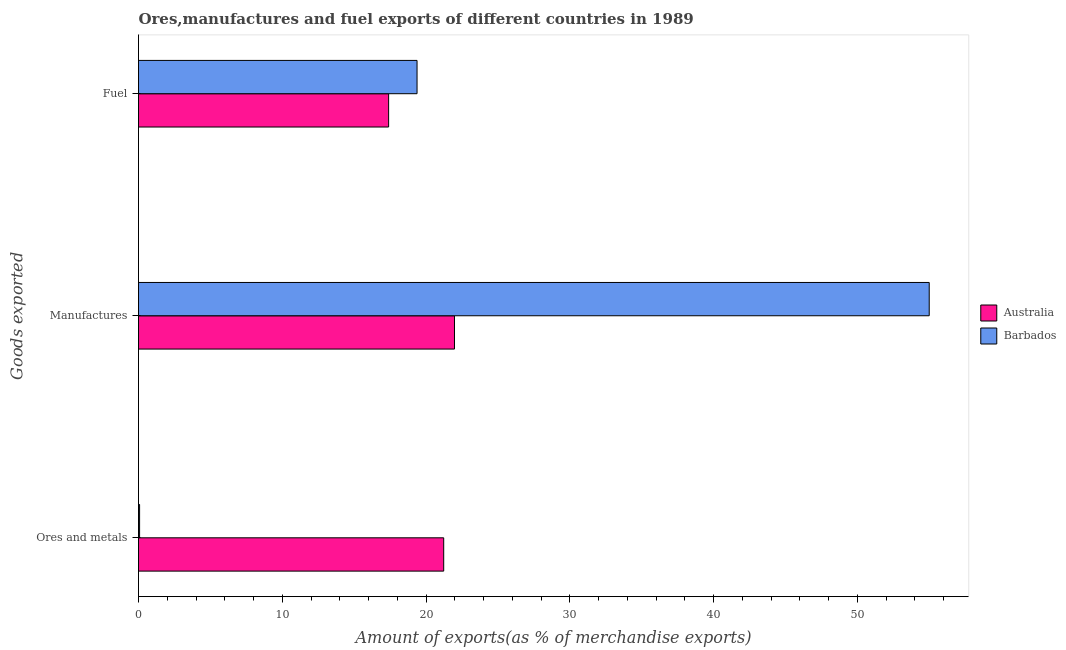Are the number of bars per tick equal to the number of legend labels?
Give a very brief answer. Yes. What is the label of the 1st group of bars from the top?
Your response must be concise. Fuel. What is the percentage of ores and metals exports in Australia?
Offer a terse response. 21.23. Across all countries, what is the maximum percentage of fuel exports?
Your response must be concise. 19.37. Across all countries, what is the minimum percentage of manufactures exports?
Your response must be concise. 21.98. In which country was the percentage of ores and metals exports maximum?
Keep it short and to the point. Australia. What is the total percentage of manufactures exports in the graph?
Your answer should be compact. 76.97. What is the difference between the percentage of fuel exports in Australia and that in Barbados?
Offer a terse response. -1.98. What is the difference between the percentage of manufactures exports in Australia and the percentage of fuel exports in Barbados?
Offer a very short reply. 2.6. What is the average percentage of fuel exports per country?
Ensure brevity in your answer.  18.38. What is the difference between the percentage of fuel exports and percentage of manufactures exports in Barbados?
Your response must be concise. -35.62. In how many countries, is the percentage of ores and metals exports greater than 50 %?
Ensure brevity in your answer.  0. What is the ratio of the percentage of manufactures exports in Barbados to that in Australia?
Offer a very short reply. 2.5. What is the difference between the highest and the second highest percentage of ores and metals exports?
Provide a succinct answer. 21.15. What is the difference between the highest and the lowest percentage of manufactures exports?
Your answer should be compact. 33.02. In how many countries, is the percentage of fuel exports greater than the average percentage of fuel exports taken over all countries?
Ensure brevity in your answer.  1. What does the 2nd bar from the top in Manufactures represents?
Offer a terse response. Australia. Are all the bars in the graph horizontal?
Your answer should be compact. Yes. How many countries are there in the graph?
Keep it short and to the point. 2. What is the difference between two consecutive major ticks on the X-axis?
Keep it short and to the point. 10. Are the values on the major ticks of X-axis written in scientific E-notation?
Your answer should be very brief. No. Where does the legend appear in the graph?
Keep it short and to the point. Center right. What is the title of the graph?
Ensure brevity in your answer.  Ores,manufactures and fuel exports of different countries in 1989. Does "Swaziland" appear as one of the legend labels in the graph?
Make the answer very short. No. What is the label or title of the X-axis?
Give a very brief answer. Amount of exports(as % of merchandise exports). What is the label or title of the Y-axis?
Your answer should be compact. Goods exported. What is the Amount of exports(as % of merchandise exports) in Australia in Ores and metals?
Offer a terse response. 21.23. What is the Amount of exports(as % of merchandise exports) of Barbados in Ores and metals?
Your answer should be very brief. 0.08. What is the Amount of exports(as % of merchandise exports) in Australia in Manufactures?
Offer a terse response. 21.98. What is the Amount of exports(as % of merchandise exports) in Barbados in Manufactures?
Offer a terse response. 54.99. What is the Amount of exports(as % of merchandise exports) of Australia in Fuel?
Make the answer very short. 17.39. What is the Amount of exports(as % of merchandise exports) of Barbados in Fuel?
Offer a terse response. 19.37. Across all Goods exported, what is the maximum Amount of exports(as % of merchandise exports) of Australia?
Your answer should be compact. 21.98. Across all Goods exported, what is the maximum Amount of exports(as % of merchandise exports) in Barbados?
Keep it short and to the point. 54.99. Across all Goods exported, what is the minimum Amount of exports(as % of merchandise exports) in Australia?
Offer a very short reply. 17.39. Across all Goods exported, what is the minimum Amount of exports(as % of merchandise exports) of Barbados?
Provide a succinct answer. 0.08. What is the total Amount of exports(as % of merchandise exports) of Australia in the graph?
Your answer should be very brief. 60.6. What is the total Amount of exports(as % of merchandise exports) in Barbados in the graph?
Your answer should be compact. 74.44. What is the difference between the Amount of exports(as % of merchandise exports) of Australia in Ores and metals and that in Manufactures?
Make the answer very short. -0.75. What is the difference between the Amount of exports(as % of merchandise exports) in Barbados in Ores and metals and that in Manufactures?
Provide a short and direct response. -54.92. What is the difference between the Amount of exports(as % of merchandise exports) of Australia in Ores and metals and that in Fuel?
Keep it short and to the point. 3.83. What is the difference between the Amount of exports(as % of merchandise exports) of Barbados in Ores and metals and that in Fuel?
Offer a very short reply. -19.3. What is the difference between the Amount of exports(as % of merchandise exports) in Australia in Manufactures and that in Fuel?
Provide a succinct answer. 4.58. What is the difference between the Amount of exports(as % of merchandise exports) in Barbados in Manufactures and that in Fuel?
Your answer should be compact. 35.62. What is the difference between the Amount of exports(as % of merchandise exports) in Australia in Ores and metals and the Amount of exports(as % of merchandise exports) in Barbados in Manufactures?
Offer a very short reply. -33.77. What is the difference between the Amount of exports(as % of merchandise exports) of Australia in Ores and metals and the Amount of exports(as % of merchandise exports) of Barbados in Fuel?
Keep it short and to the point. 1.85. What is the difference between the Amount of exports(as % of merchandise exports) in Australia in Manufactures and the Amount of exports(as % of merchandise exports) in Barbados in Fuel?
Make the answer very short. 2.6. What is the average Amount of exports(as % of merchandise exports) of Australia per Goods exported?
Your answer should be compact. 20.2. What is the average Amount of exports(as % of merchandise exports) in Barbados per Goods exported?
Your response must be concise. 24.81. What is the difference between the Amount of exports(as % of merchandise exports) of Australia and Amount of exports(as % of merchandise exports) of Barbados in Ores and metals?
Give a very brief answer. 21.15. What is the difference between the Amount of exports(as % of merchandise exports) of Australia and Amount of exports(as % of merchandise exports) of Barbados in Manufactures?
Your response must be concise. -33.02. What is the difference between the Amount of exports(as % of merchandise exports) of Australia and Amount of exports(as % of merchandise exports) of Barbados in Fuel?
Keep it short and to the point. -1.98. What is the ratio of the Amount of exports(as % of merchandise exports) of Australia in Ores and metals to that in Manufactures?
Make the answer very short. 0.97. What is the ratio of the Amount of exports(as % of merchandise exports) of Barbados in Ores and metals to that in Manufactures?
Your response must be concise. 0. What is the ratio of the Amount of exports(as % of merchandise exports) of Australia in Ores and metals to that in Fuel?
Offer a terse response. 1.22. What is the ratio of the Amount of exports(as % of merchandise exports) of Barbados in Ores and metals to that in Fuel?
Your answer should be compact. 0. What is the ratio of the Amount of exports(as % of merchandise exports) in Australia in Manufactures to that in Fuel?
Your answer should be very brief. 1.26. What is the ratio of the Amount of exports(as % of merchandise exports) of Barbados in Manufactures to that in Fuel?
Keep it short and to the point. 2.84. What is the difference between the highest and the second highest Amount of exports(as % of merchandise exports) in Australia?
Your answer should be compact. 0.75. What is the difference between the highest and the second highest Amount of exports(as % of merchandise exports) of Barbados?
Keep it short and to the point. 35.62. What is the difference between the highest and the lowest Amount of exports(as % of merchandise exports) of Australia?
Provide a short and direct response. 4.58. What is the difference between the highest and the lowest Amount of exports(as % of merchandise exports) of Barbados?
Provide a succinct answer. 54.92. 